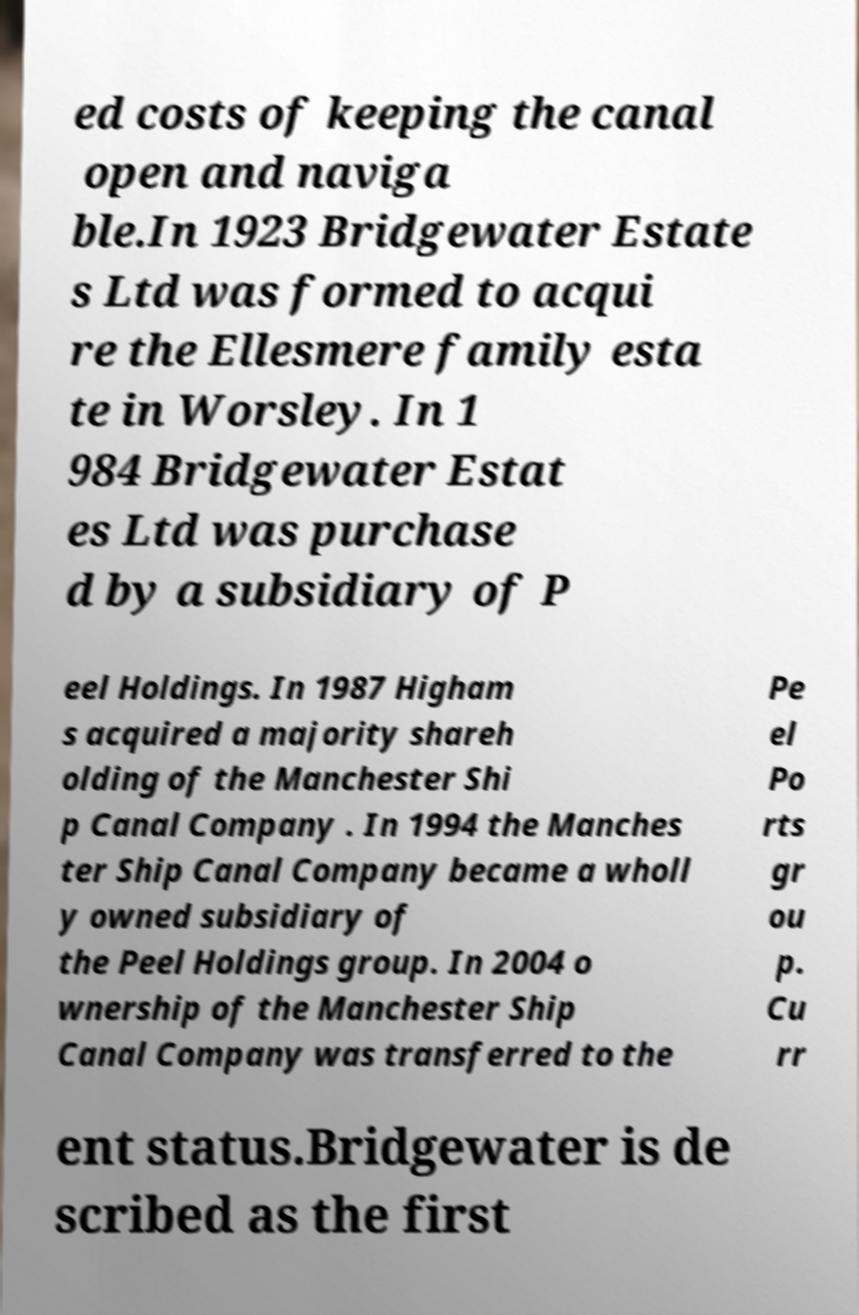Please identify and transcribe the text found in this image. ed costs of keeping the canal open and naviga ble.In 1923 Bridgewater Estate s Ltd was formed to acqui re the Ellesmere family esta te in Worsley. In 1 984 Bridgewater Estat es Ltd was purchase d by a subsidiary of P eel Holdings. In 1987 Higham s acquired a majority shareh olding of the Manchester Shi p Canal Company . In 1994 the Manches ter Ship Canal Company became a wholl y owned subsidiary of the Peel Holdings group. In 2004 o wnership of the Manchester Ship Canal Company was transferred to the Pe el Po rts gr ou p. Cu rr ent status.Bridgewater is de scribed as the first 